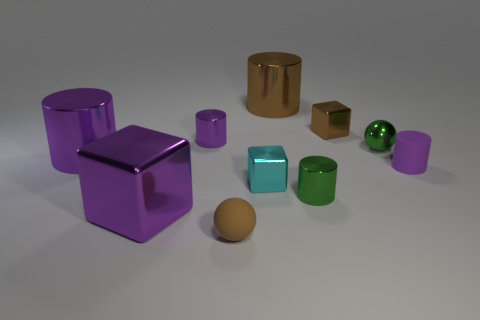There is a metallic cube behind the metal sphere; is its size the same as the green metal thing in front of the small cyan object? No, the metallic cube behind the metal sphere is larger than the green metal cube in front of the small cyan cube. The purple metallic cube has sides that are approximately twice the length of the green cube's sides. 